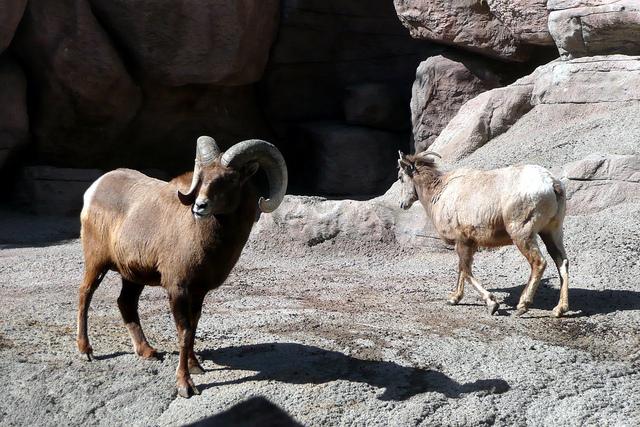What way are they looking?
Short answer required. Left. What color is the closer ram?
Concise answer only. Brown. Where are they going?
Write a very short answer. Home. Is there a cave?
Give a very brief answer. Yes. Are both Rams male?
Concise answer only. No. 